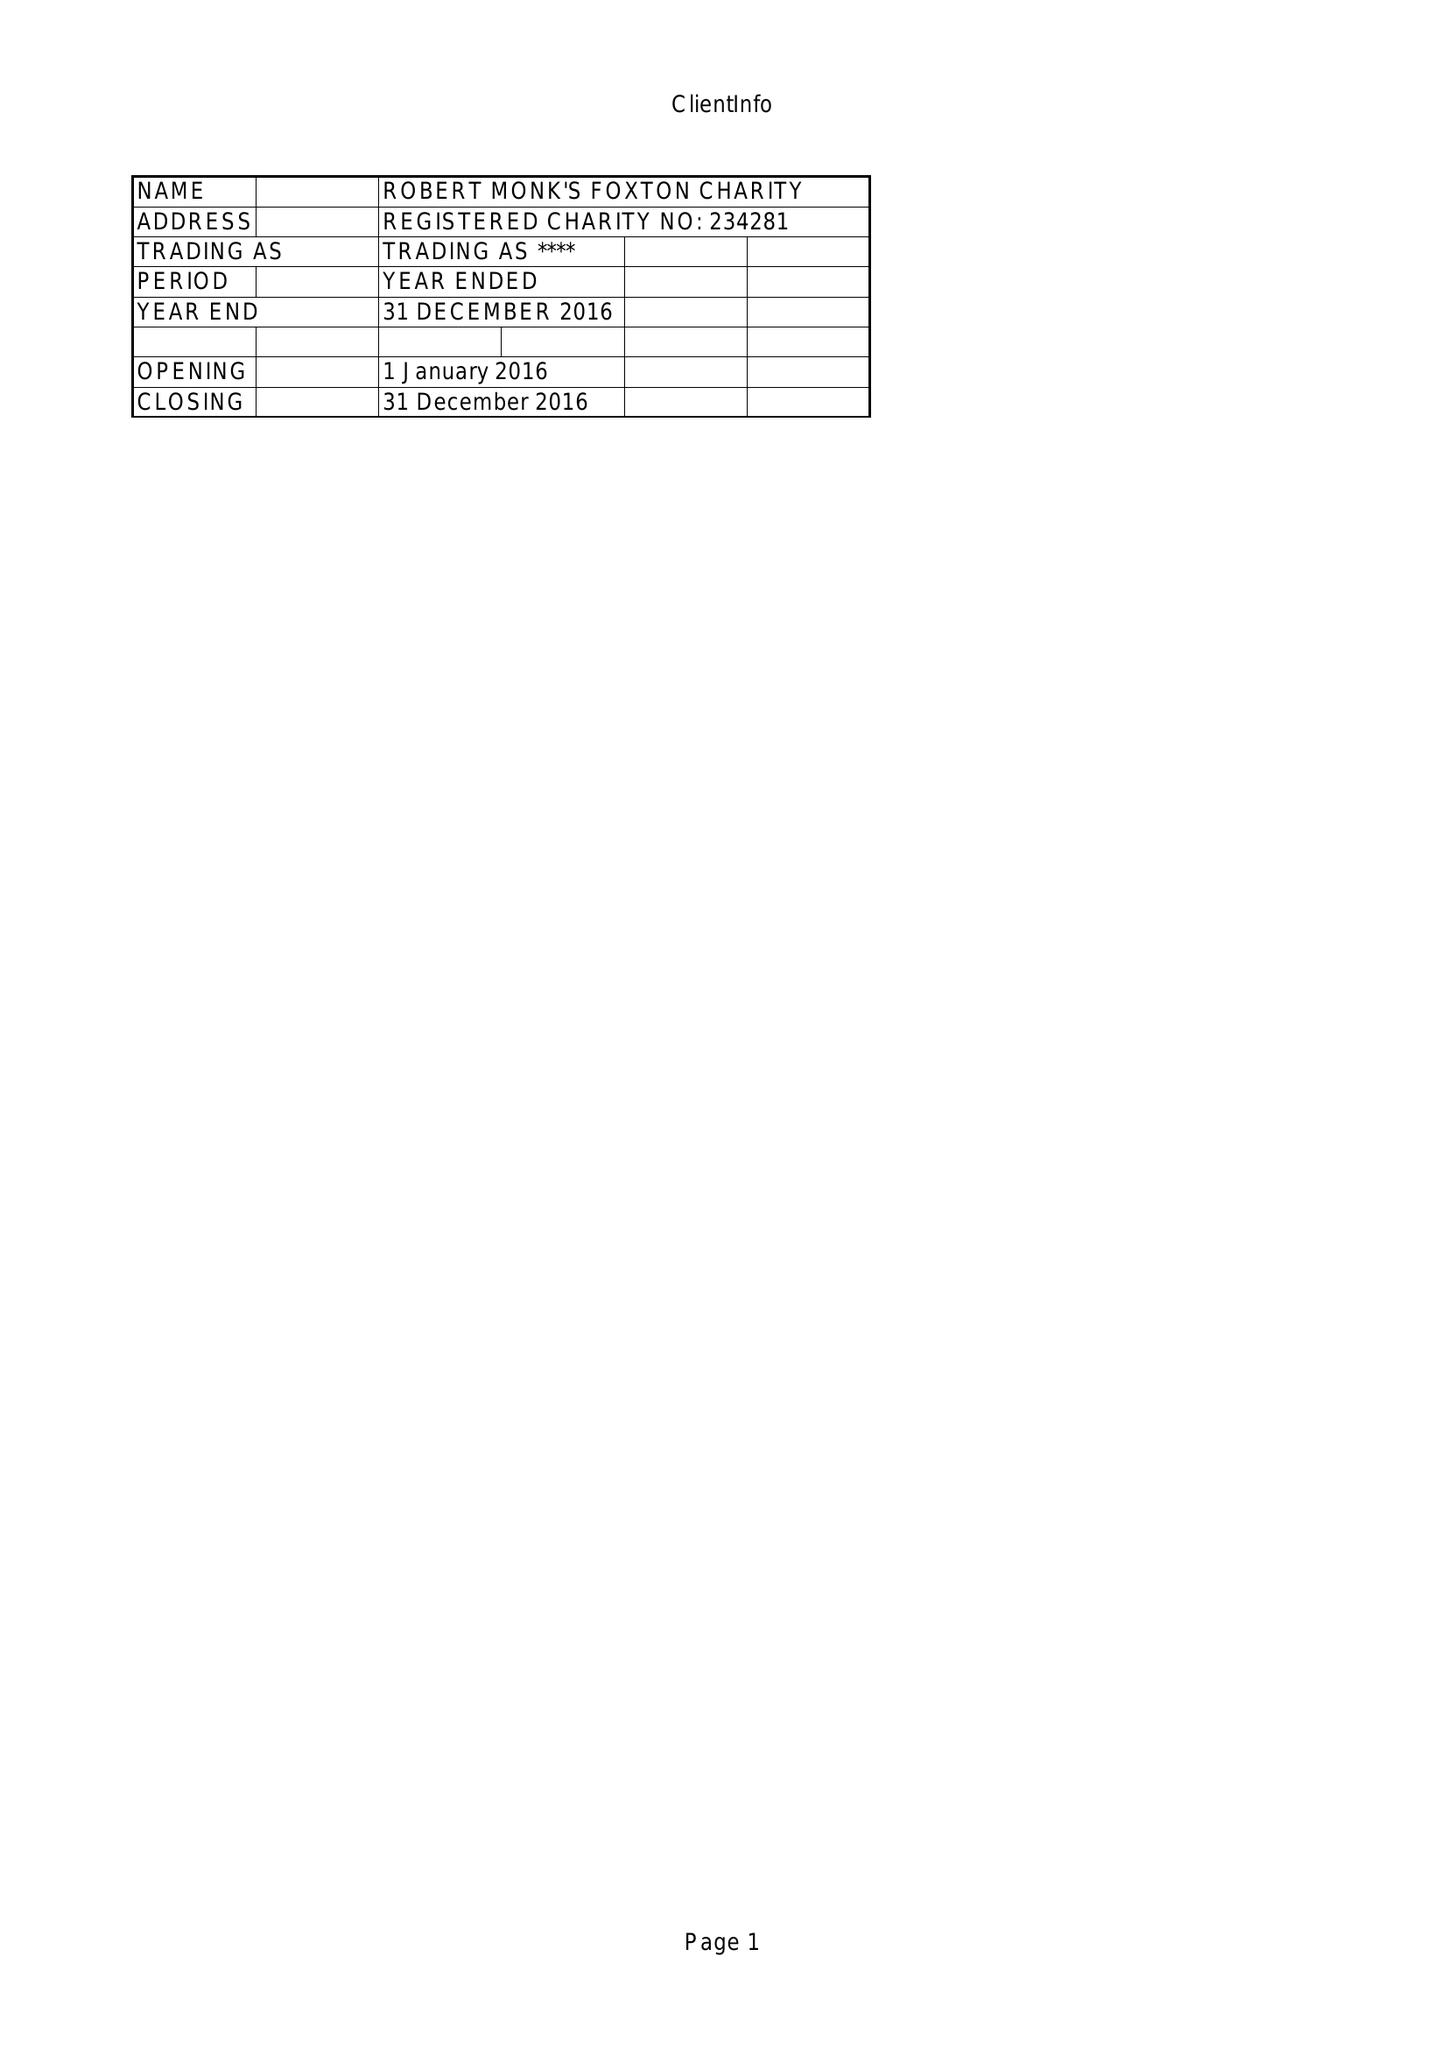What is the value for the address__street_line?
Answer the question using a single word or phrase. 49 MIDDLE STREET 